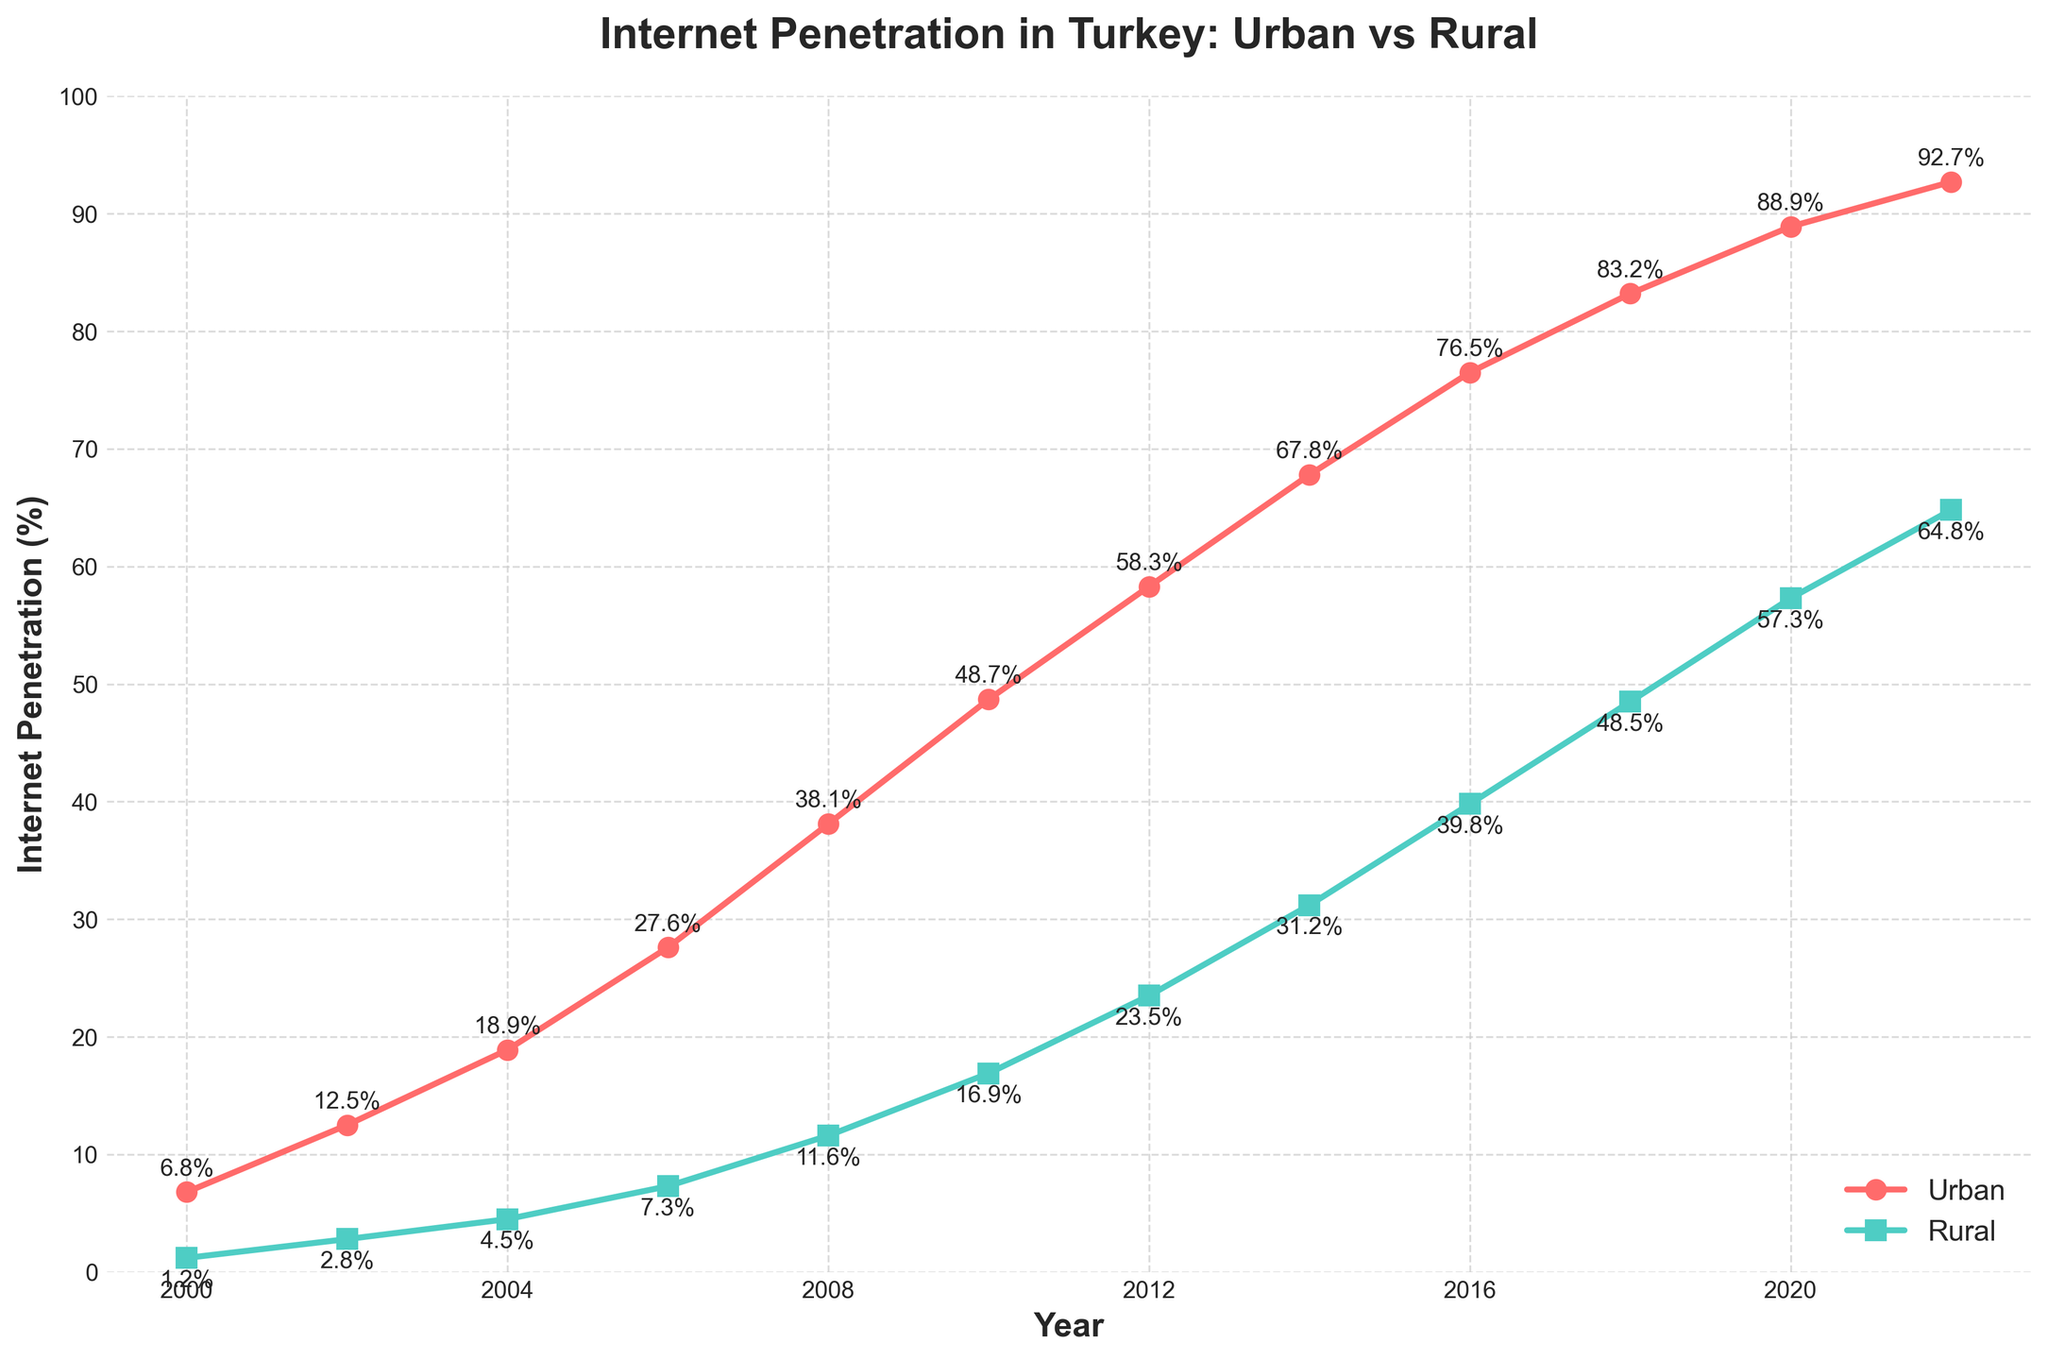What is the Internet penetration rate in urban areas in 2006? Locate the year 2006 on the x-axis. Look at the corresponding point for urban areas, which is highlighted in red, and check the value on the y-axis.
Answer: 27.6% How much did the rural Internet penetration rate increase between 2010 and 2020? Find the values for rural Internet penetration in 2010 (16.9%) and 2020 (57.3%) on the y-axis. Calculate the difference: 57.3 - 16.9.
Answer: 40.4% Did urban or rural areas have a higher increase in Internet penetration from 2000 to 2022? Find the initial (2000) and final (2022) Internet penetration rates for both urban and rural areas. Urban: 92.7% - 6.8% = 85.9%; Rural: 64.8% - 1.2% = 63.6%. Compare the two results.
Answer: Urban What is the difference in Internet penetration rates between urban and rural areas in 2022? Look at the values for urban (92.7%) and rural (64.8%) Internet penetration in 2022. Calculate the difference: 92.7 - 64.8.
Answer: 27.9% How many years did it take for rural Internet penetration to reach at least 50%? Identify the year when rural Internet penetration first exceeded 50%. The year is 2018, and the start year is 2000. 2018 - 2000.
Answer: 18 years Which year had the largest gap between urban and rural Internet penetration rates? Determine the difference between the urban and rural values for each year. Identify the year with the largest difference. In 2010: 48.7 - 16.9 = 31.8%. Verify that 31.8% is the maximum gap.
Answer: 2010 What is the average Internet penetration rate in rural areas between 2008 and 2018? Find the rural Internet penetration rates for the years 2008 (11.6%), 2010 (16.9%), 2012 (23.5%), 2014 (31.2%), 2016 (39.8%), and 2018 (48.5%). Compute the sum and divide by the number of years. (11.6 + 16.9 + 23.5 + 31.2 + 39.8 + 48.5) / 6.
Answer: 28.6% In what year did urban Internet penetration first exceed 50%? Locate the year in which the urban Internet penetration rate surpasses 50% on the x-axis and check the corresponding value on the y-axis. The year is 2010.
Answer: 2010 By how many percentage points did urban Internet penetration surpass rural penetration in 2008? Find the urban (38.1%) and rural (11.6%) Internet penetration rates in 2008. Calculate the difference: 38.1 - 11.6.
Answer: 26.5% What is the trend observed in the Internet penetration rates for both urban and rural areas from 2000 to 2022? Observe the overall direction of the lines for both urban and rural areas from left (2000) to right (2022). Both lines show a consistent upward trend, indicating an increase in Internet penetration rates over time.
Answer: Upward trend 